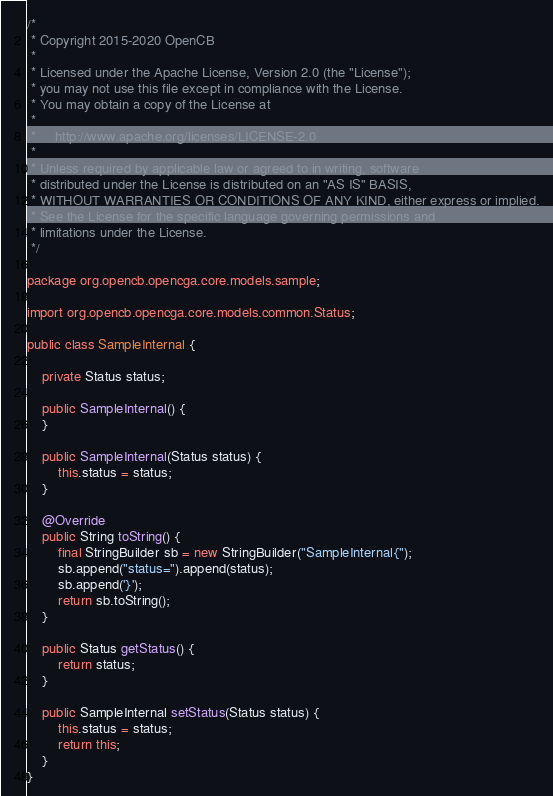<code> <loc_0><loc_0><loc_500><loc_500><_Java_>/*
 * Copyright 2015-2020 OpenCB
 *
 * Licensed under the Apache License, Version 2.0 (the "License");
 * you may not use this file except in compliance with the License.
 * You may obtain a copy of the License at
 *
 *     http://www.apache.org/licenses/LICENSE-2.0
 *
 * Unless required by applicable law or agreed to in writing, software
 * distributed under the License is distributed on an "AS IS" BASIS,
 * WITHOUT WARRANTIES OR CONDITIONS OF ANY KIND, either express or implied.
 * See the License for the specific language governing permissions and
 * limitations under the License.
 */

package org.opencb.opencga.core.models.sample;

import org.opencb.opencga.core.models.common.Status;

public class SampleInternal {

    private Status status;

    public SampleInternal() {
    }

    public SampleInternal(Status status) {
        this.status = status;
    }

    @Override
    public String toString() {
        final StringBuilder sb = new StringBuilder("SampleInternal{");
        sb.append("status=").append(status);
        sb.append('}');
        return sb.toString();
    }

    public Status getStatus() {
        return status;
    }

    public SampleInternal setStatus(Status status) {
        this.status = status;
        return this;
    }
}
</code> 